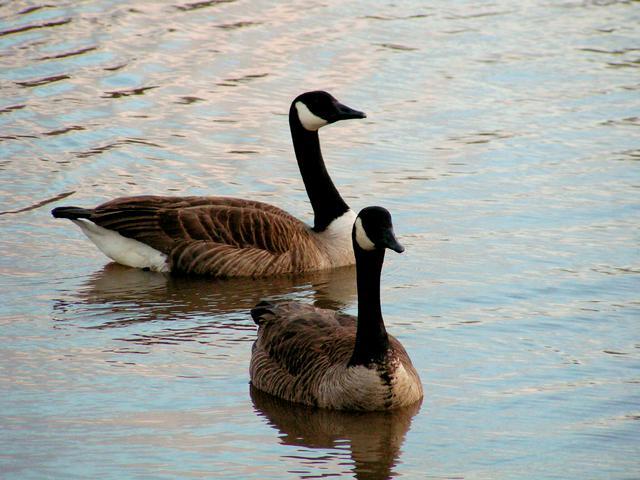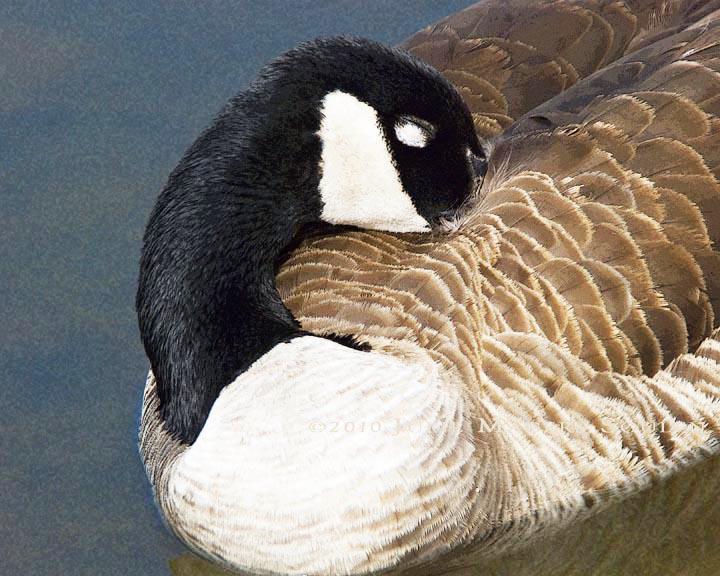The first image is the image on the left, the second image is the image on the right. For the images shown, is this caption "There are two birds in total." true? Answer yes or no. No. The first image is the image on the left, the second image is the image on the right. Considering the images on both sides, is "All the ducks are sleeping." valid? Answer yes or no. No. 